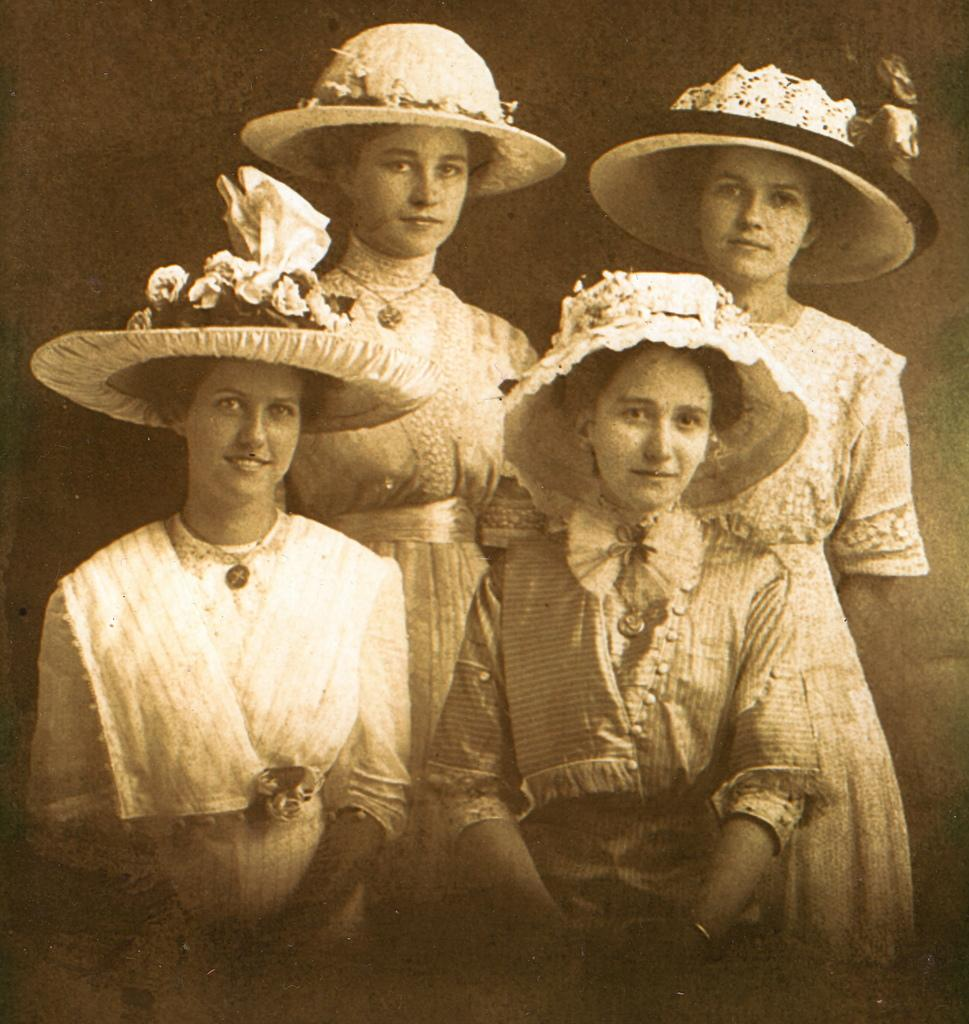What object is present in the image that typically holds a photograph? There is a photo frame in the image. What can be seen inside the photo frame? The photo contains four women. What are the women wearing on their heads? The women are wearing hats. What color are the dresses worn by the women in the photo? The women are wearing white dresses. Where are the women standing in relation to the photo frame? The women are standing near a wall. Are there any structures visible in the image? There is no information about structures in the provided facts, so we cannot determine if any are visible in the image. Can you see any boats in the image? There is no information about boats in the provided facts, so we cannot determine if any are visible in the image. 